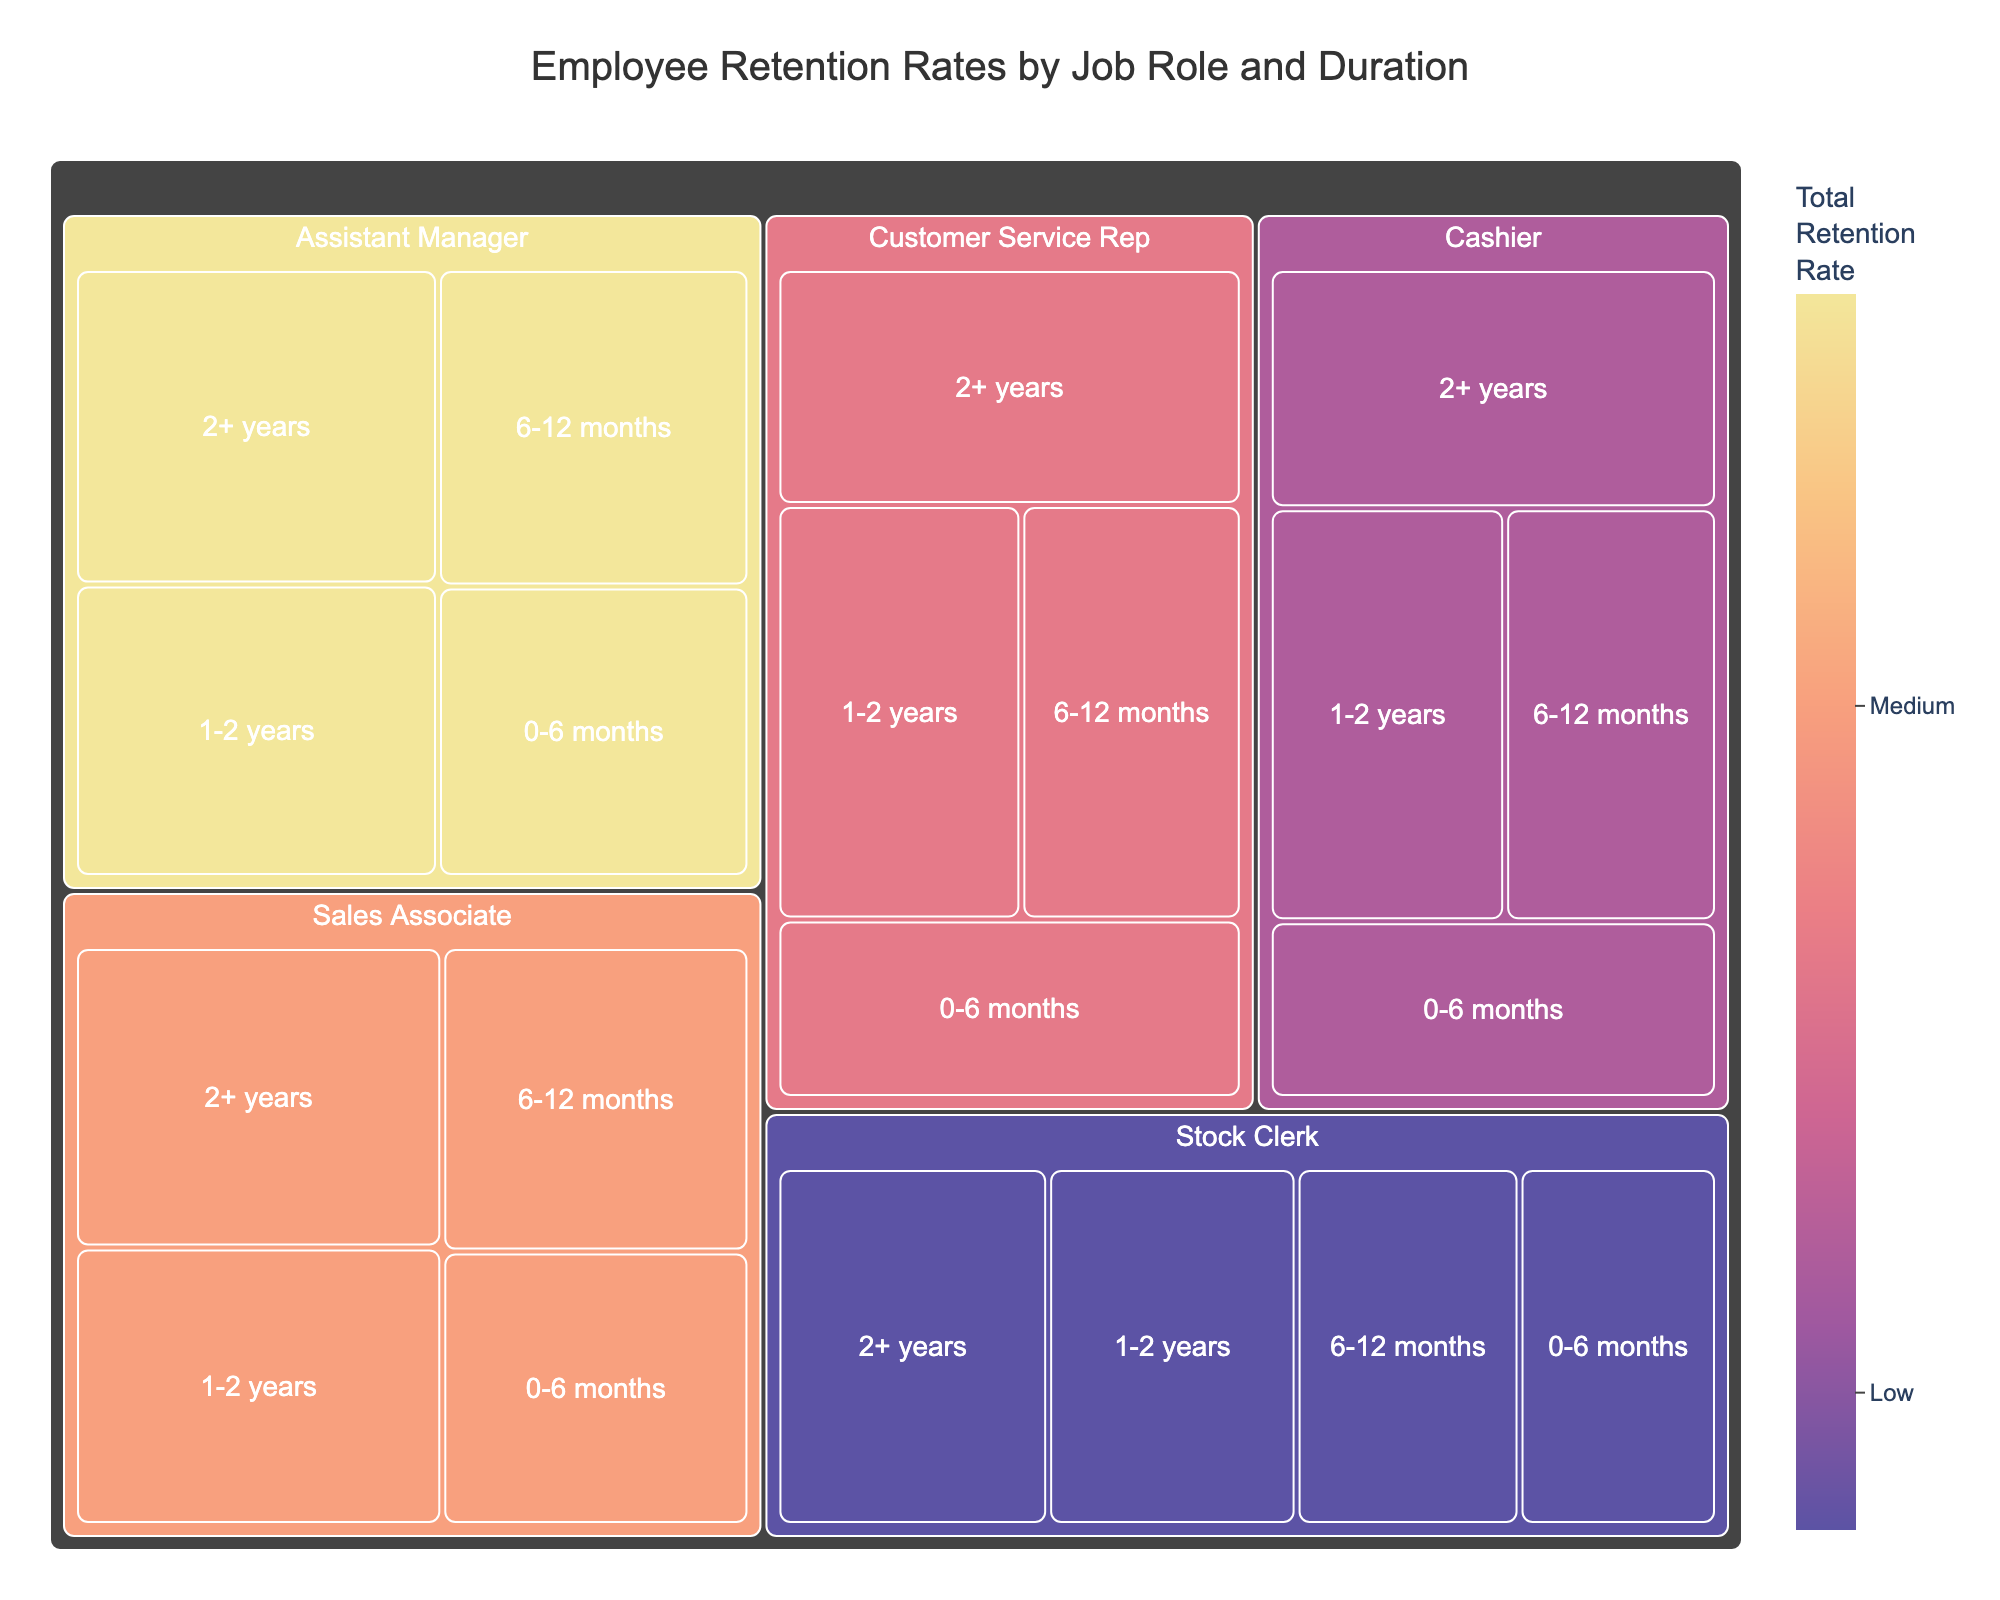What is the highest retention rate for Cashiers and in which duration? To find the highest retention rate for Cashiers, look for the Cashier section and find the maximum percentage. It is categorized by duration.
Answer: 88% in 2+ years Which job role has the highest overall retention rate at the 2+ years duration? Check the treemap under the 2+ years duration and identify which job role has the largest percentage.
Answer: Assistant Manager How does the retention rate for Sales Associates in the 1-2 years duration compare to that of Stock Clerks in the same duration? Look at the 1-2 years duration for both Sales Associates and Stock Clerks and compare their percentages.
Answer: Sales Associates: 85%, Stock Clerks: 78% What is the total retention rate for Customer Service Reps in all categories combined? Summing up retention rates across all durations for Customer Service Reps: 68 + 75 + 83 + 90.
Answer: 316% Which duration has the lowest retention rate for the Assistant Manager position? Look for the duration under the Assistant Manager section and identify the lowest percentage.
Answer: 0-6 months What is the difference in retention rate between Cashiers and Customer Service Reps in the 6-12 months duration? Subtract the retention rate for Customer Service Reps from that of Cashiers in the 6-12 months duration.
Answer: Cashiers: 72%, Customer Service Reps: 75%; Difference: 3% How does the on-boarding retention rate (0-6 months) for Stock Clerks compare to Cashiers? Look at the 0-6 months duration and compare the retention rates of Stock Clerks and Cashiers.
Answer: Stock Clerks: 62%, Cashiers: 65% Which job role shows the most significant improvement in retention rate from 0-6 months to 2+ years? Calculate the difference from 0-6 months to 2+ years for each job role and identify the maximum difference.
Answer: Assistant Manager (95%-75% = 20%) What color is associated with job roles having the highest total retention rate in the treemap? Observe the color corresponding to the highest total retention rates (Assistant Manager) on the treemap.
Answer: Darker shade (red or deep purple tones) What is the retention rate for Customer Service Reps with 1-2 years of experience? Locate the Customer Service Rep section and read off the retention rate in the 1-2 years duration.
Answer: 83% 